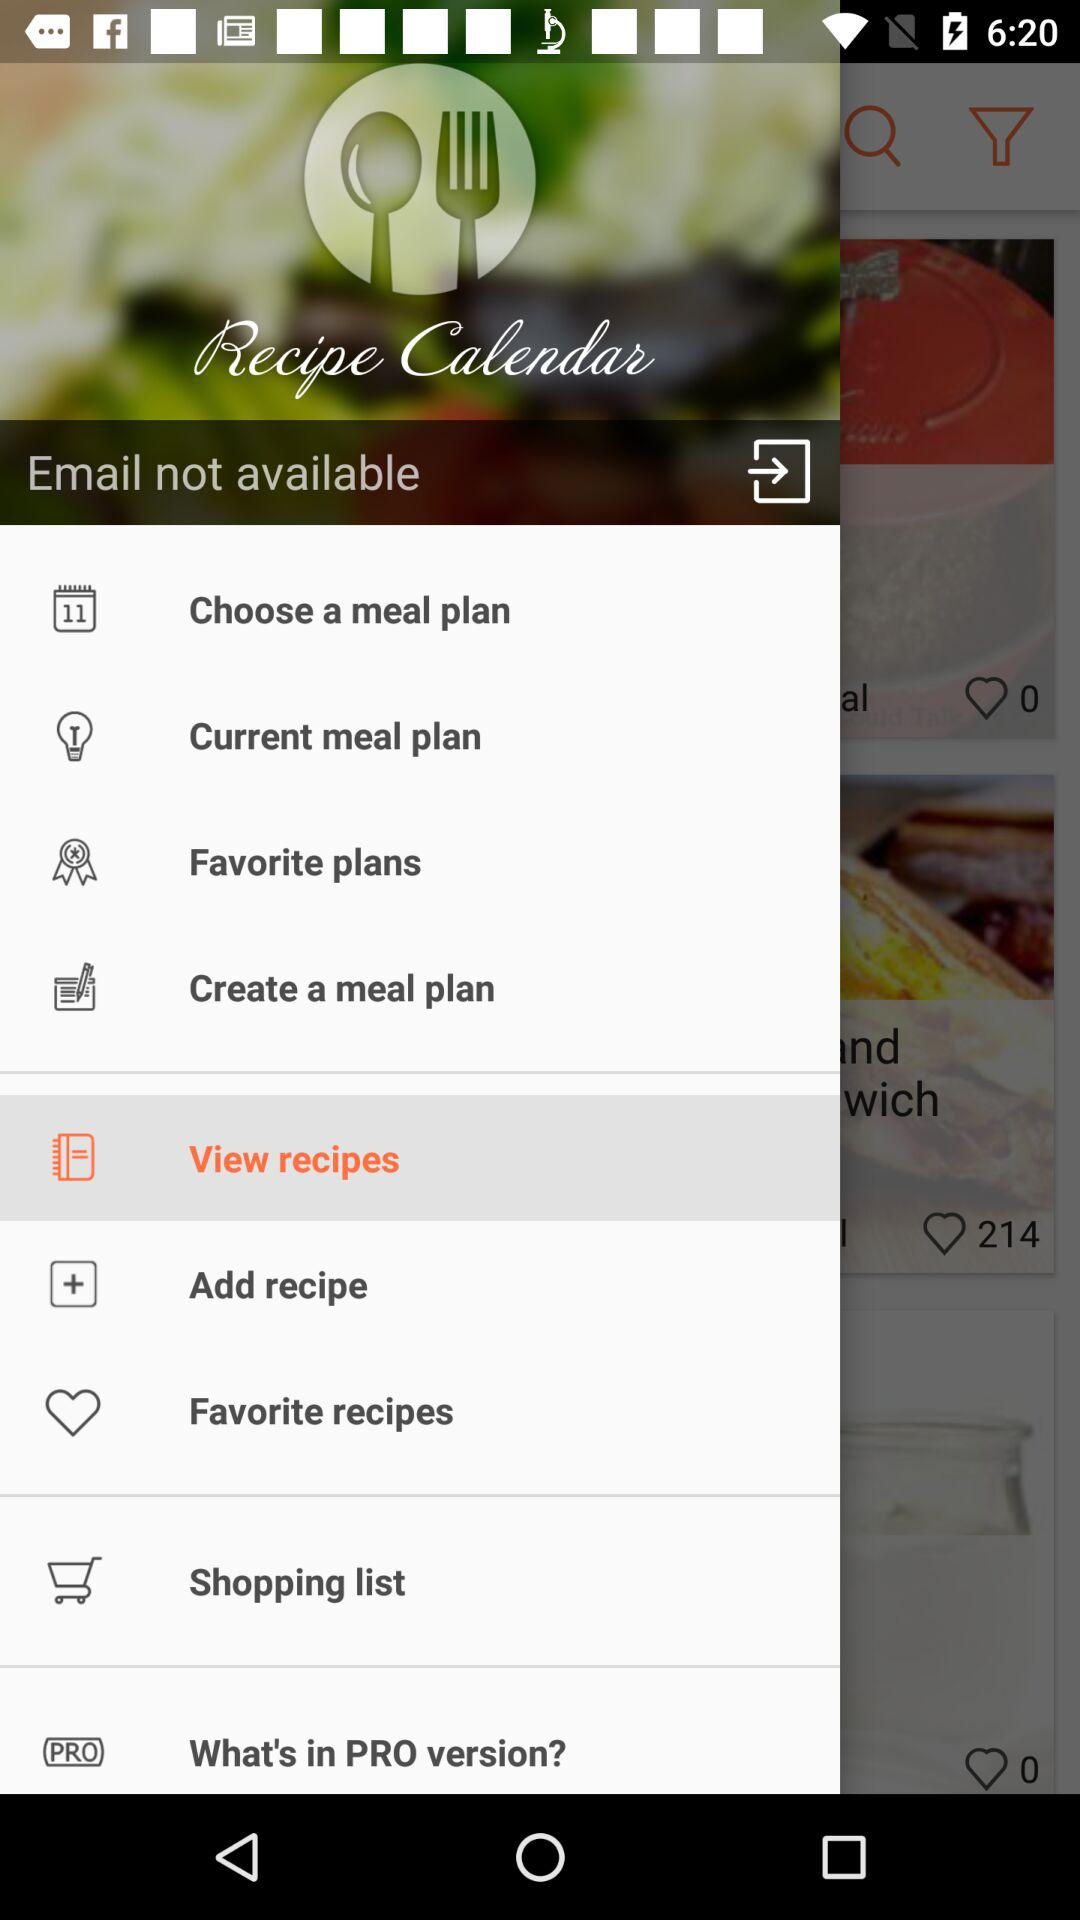Which item is selected? The selected item is "View recipes". 